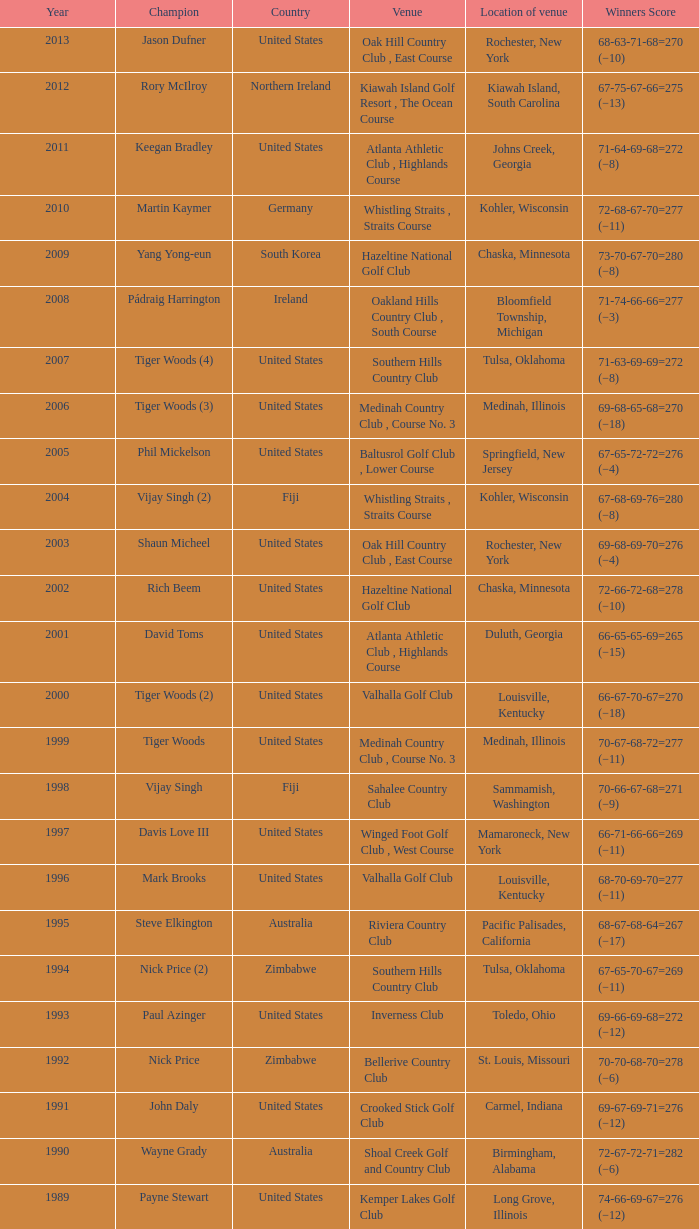Where is the Bellerive Country Club venue located? St. Louis, Missouri. 